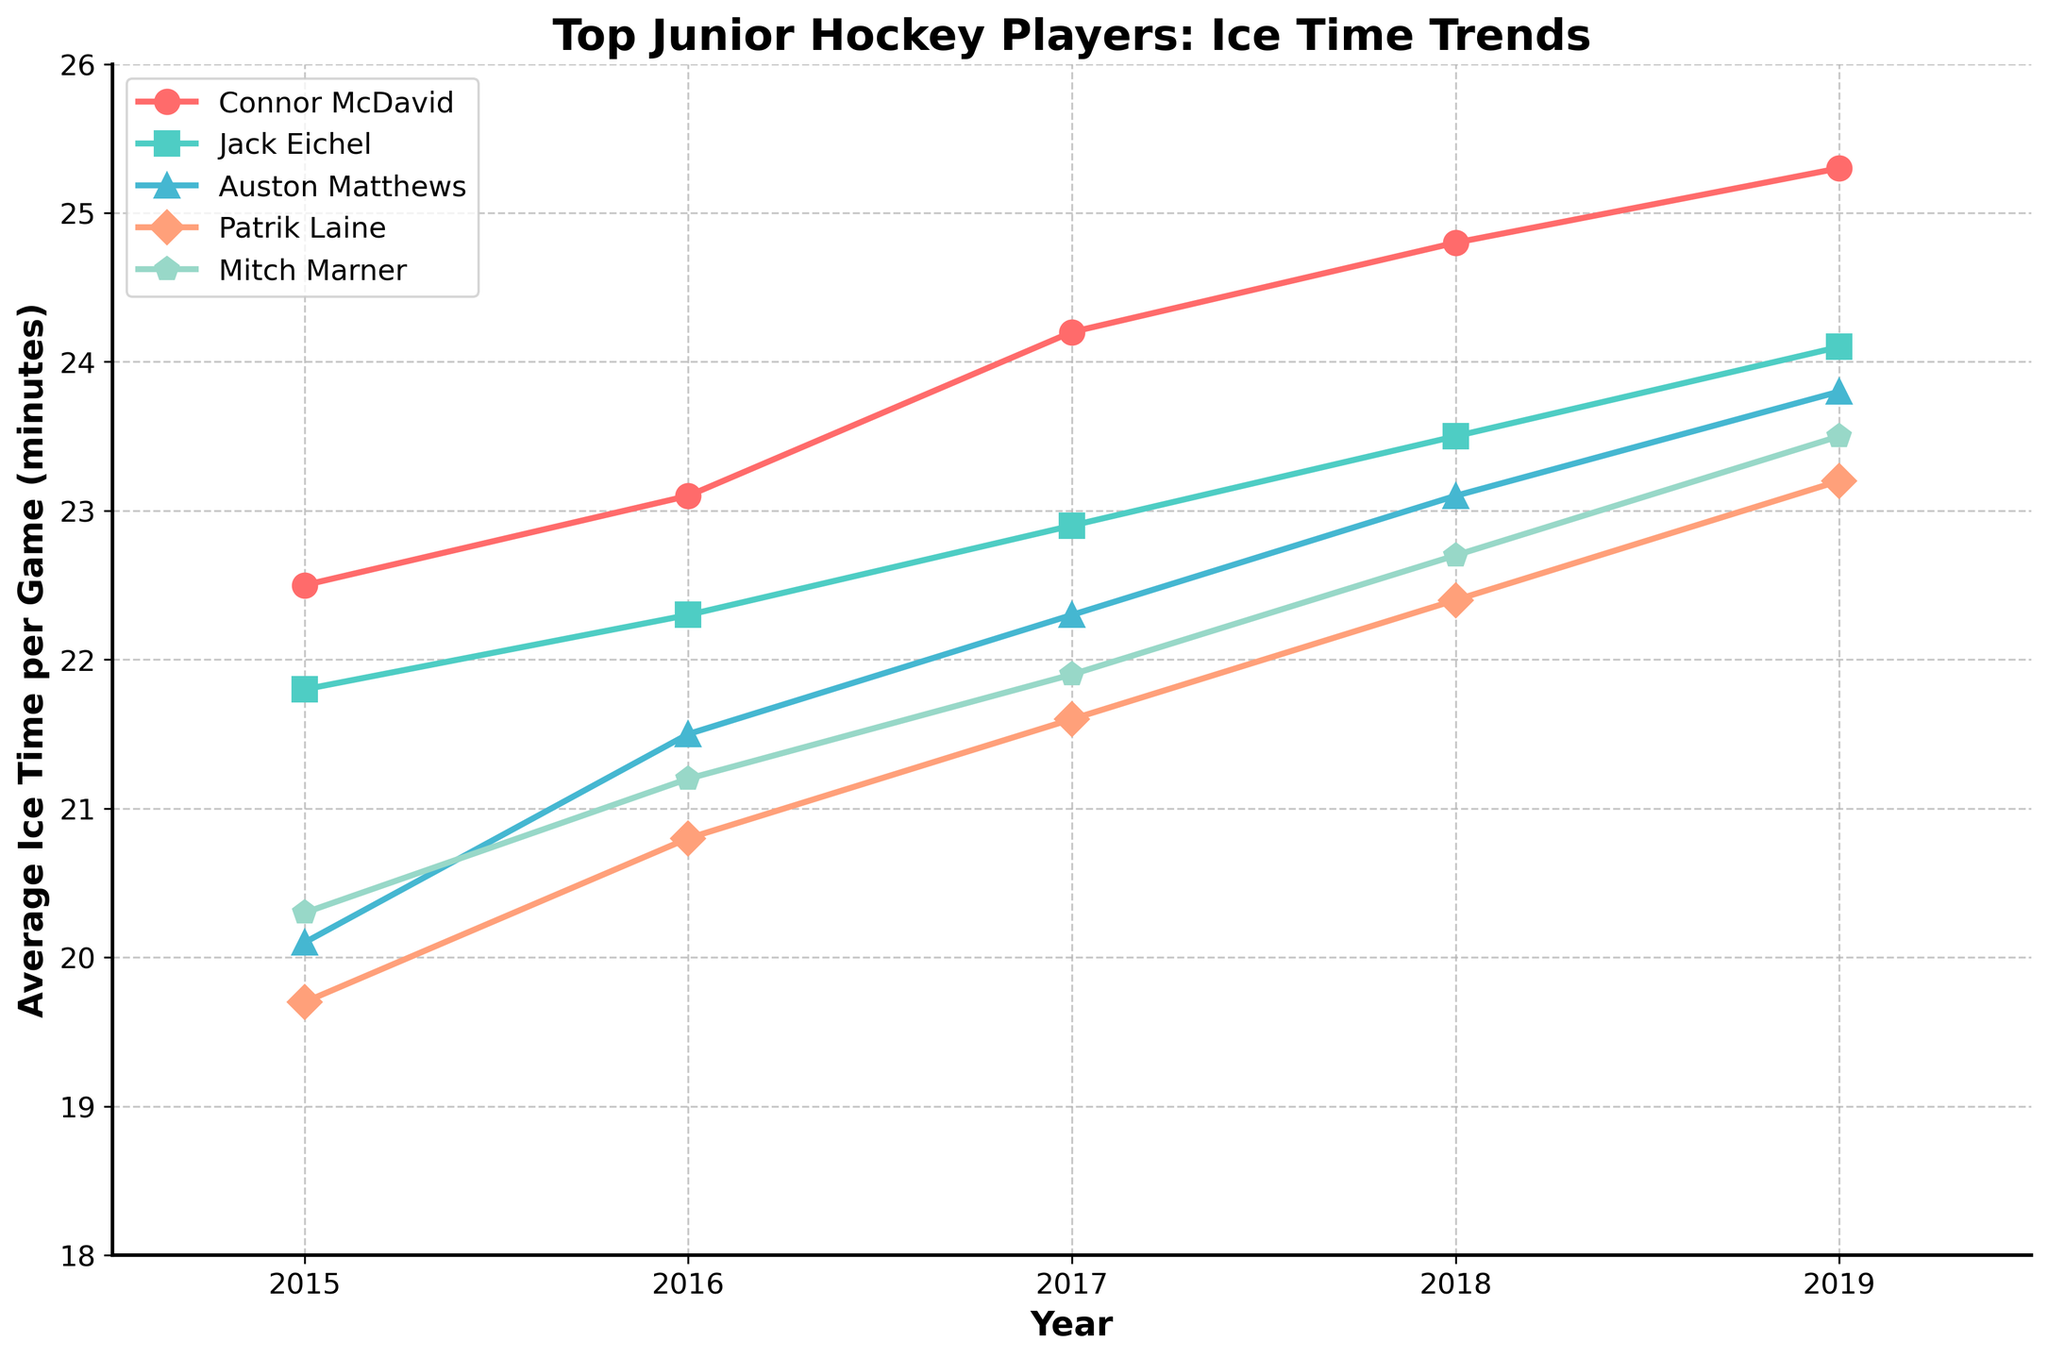Which player had the highest average ice time in 2019? To find the player with the highest average ice time in 2019, look at the values for each player in 2019. Connor McDavid has the highest value at 25.3 minutes.
Answer: Connor McDavid Which player showed the greatest increase in average ice time from 2015 to 2019? Calculate the increase for each player by subtracting the 2015 value from the 2019 value. Connor McDavid: 25.3 - 22.5 = 2.8, Jack Eichel: 24.1 - 21.8 = 2.3, Auston Matthews: 23.8 - 20.1 = 3.7, Patrik Laine: 23.2 - 19.7 = 3.5, Mitch Marner: 23.5 - 20.3 = 3.2. Auston Matthews showed the greatest increase.
Answer: Auston Matthews Who had the lowest average ice time in 2017 and how much was it? Look at the data for the year 2017 and find the smallest value. Patrik Laine had the lowest average ice time in 2017 with 21.6 minutes.
Answer: Patrik Laine, 21.6 Did Mitch Marner's average ice time ever exceed 23 minutes in any of the years? Check all the values for Mitch Marner across the years. In 2019, his average ice time was 23.5 minutes, which is over 23 minutes.
Answer: Yes Between 2015 and 2019, which year saw the greatest increase in average ice time for Jack Eichel? Calculate the increase from year to year for Jack Eichel: 2016: 22.3 - 21.8 = 0.5, 2017: 22.9 - 22.3 = 0.6, 2018: 23.5 - 22.9 = 0.6, 2019: 24.1 - 23.5 = 0.6. The greatest increase happened in 2017, 2018, and 2019 with an equal increase of 0.6 minutes each.
Answer: 2017, 2018, 2019 What is the total average ice time for all players combined in 2018? Sum the average ice time for all players in 2018: 24.8 (McDavid) + 23.5 (Eichel) + 23.1 (Matthews) + 22.4 (Laine) + 22.7 (Marner) = 116.5 minutes.
Answer: 116.5 minutes Which player had the most consistent increase in ice time over the years? Determine the increase for each player each year and check for consistency. Connor McDavid's ice time consistently increases year over year: 23.1-22.5 = 0.6, 24.2-23.1 = 1.1, 24.8-24.2 = 0.6, 25.3-24.8 = 0.5, etc.
Answer: Connor McDavid Which year saw the highest average ice time for Auston Matthews? Compare the values for Auston Matthews across the years: 2019 has the highest value at 23.8 minutes.
Answer: 2019 